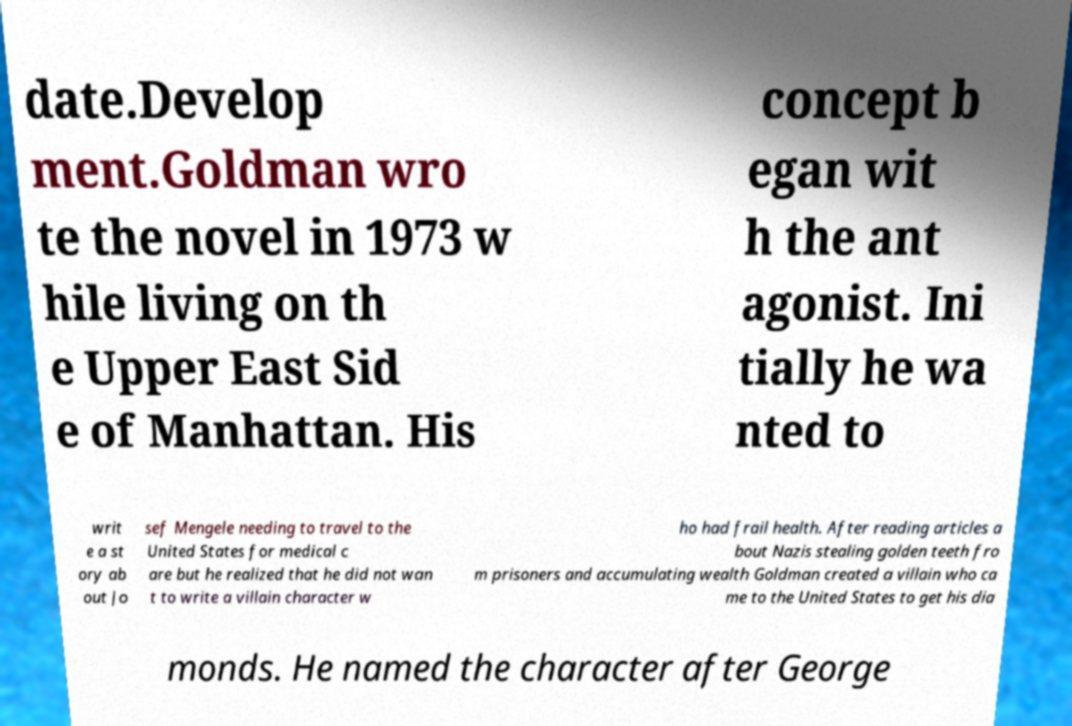There's text embedded in this image that I need extracted. Can you transcribe it verbatim? date.Develop ment.Goldman wro te the novel in 1973 w hile living on th e Upper East Sid e of Manhattan. His concept b egan wit h the ant agonist. Ini tially he wa nted to writ e a st ory ab out Jo sef Mengele needing to travel to the United States for medical c are but he realized that he did not wan t to write a villain character w ho had frail health. After reading articles a bout Nazis stealing golden teeth fro m prisoners and accumulating wealth Goldman created a villain who ca me to the United States to get his dia monds. He named the character after George 